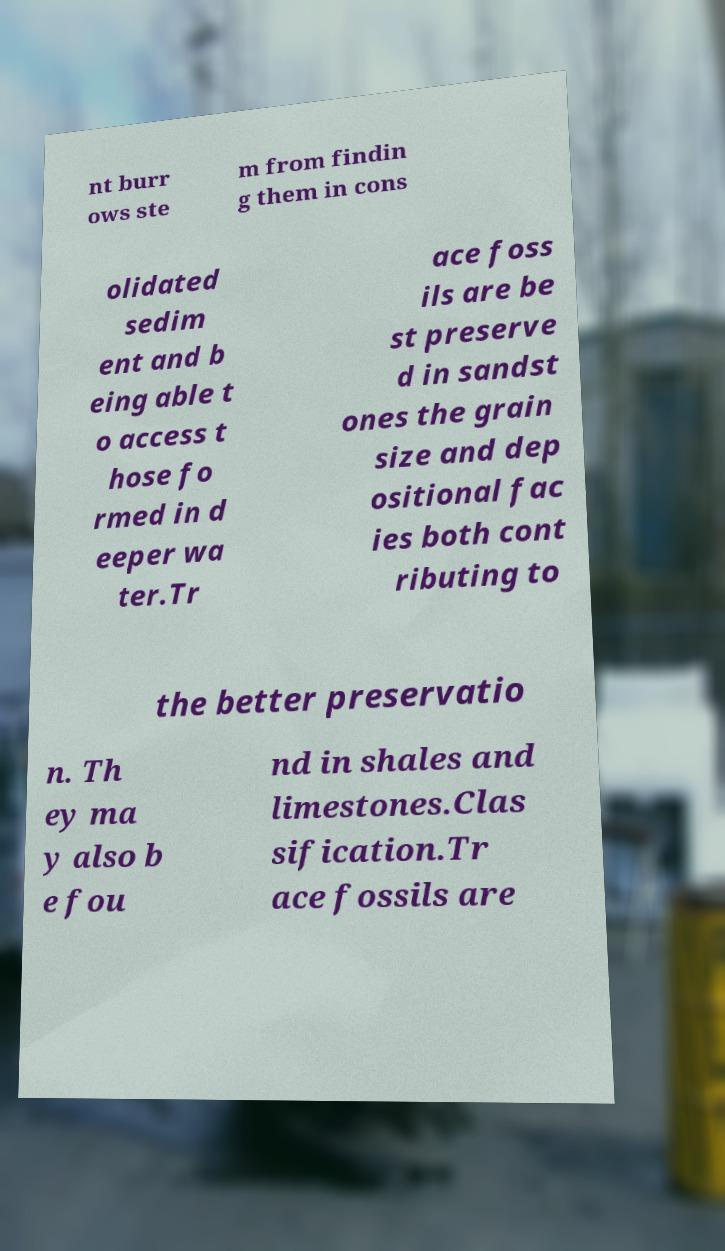What messages or text are displayed in this image? I need them in a readable, typed format. nt burr ows ste m from findin g them in cons olidated sedim ent and b eing able t o access t hose fo rmed in d eeper wa ter.Tr ace foss ils are be st preserve d in sandst ones the grain size and dep ositional fac ies both cont ributing to the better preservatio n. Th ey ma y also b e fou nd in shales and limestones.Clas sification.Tr ace fossils are 